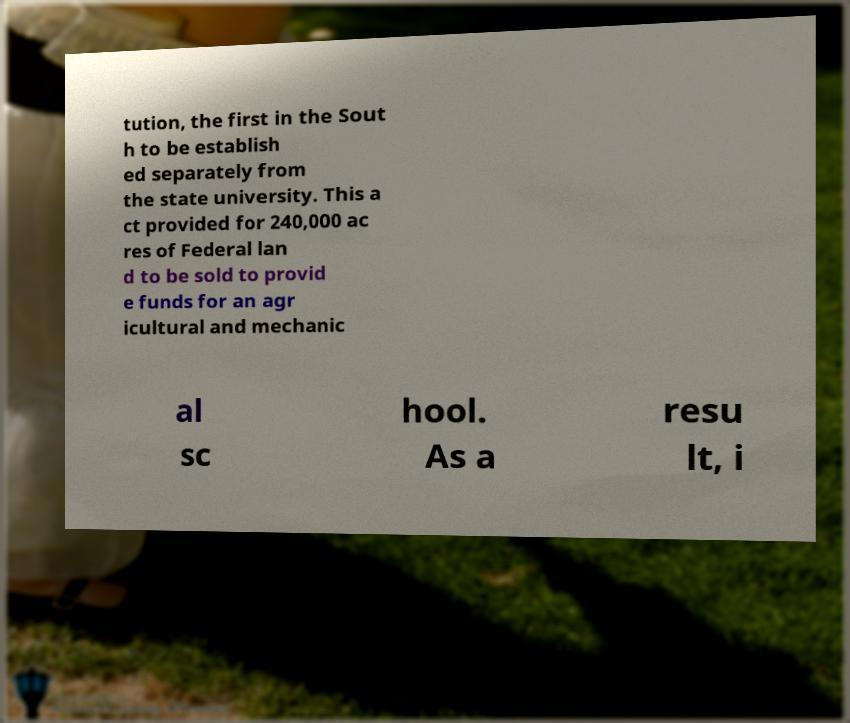I need the written content from this picture converted into text. Can you do that? tution, the first in the Sout h to be establish ed separately from the state university. This a ct provided for 240,000 ac res of Federal lan d to be sold to provid e funds for an agr icultural and mechanic al sc hool. As a resu lt, i 